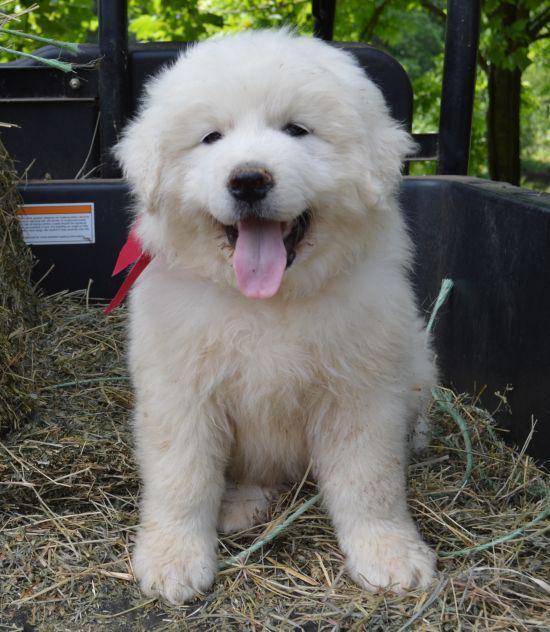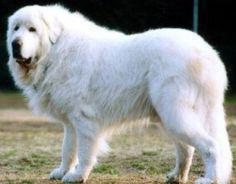The first image is the image on the left, the second image is the image on the right. Assess this claim about the two images: "The left image contains one non-standing white puppy, while the right image contains one standing white adult dog.". Correct or not? Answer yes or no. Yes. The first image is the image on the left, the second image is the image on the right. Analyze the images presented: Is the assertion "There is one puppy and one adult dog" valid? Answer yes or no. Yes. 